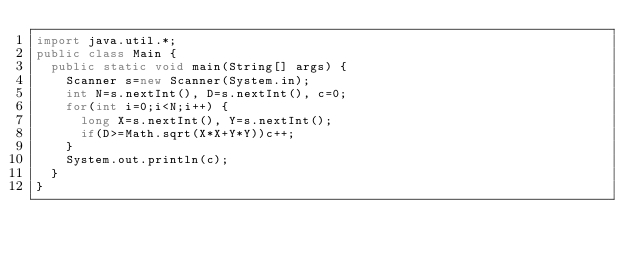<code> <loc_0><loc_0><loc_500><loc_500><_Java_>import java.util.*;
public class Main {
	public static void main(String[] args) {
		Scanner s=new Scanner(System.in);
		int N=s.nextInt(), D=s.nextInt(), c=0;
		for(int i=0;i<N;i++) {
			long X=s.nextInt(), Y=s.nextInt();
			if(D>=Math.sqrt(X*X+Y*Y))c++;
		}
		System.out.println(c);
	}
}
</code> 